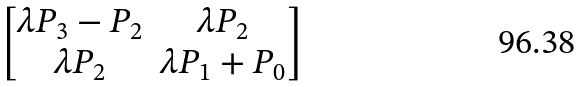Convert formula to latex. <formula><loc_0><loc_0><loc_500><loc_500>\begin{bmatrix} \lambda P _ { 3 } - P _ { 2 } & \lambda P _ { 2 } \\ \lambda P _ { 2 } & \lambda P _ { 1 } + P _ { 0 } \end{bmatrix}</formula> 